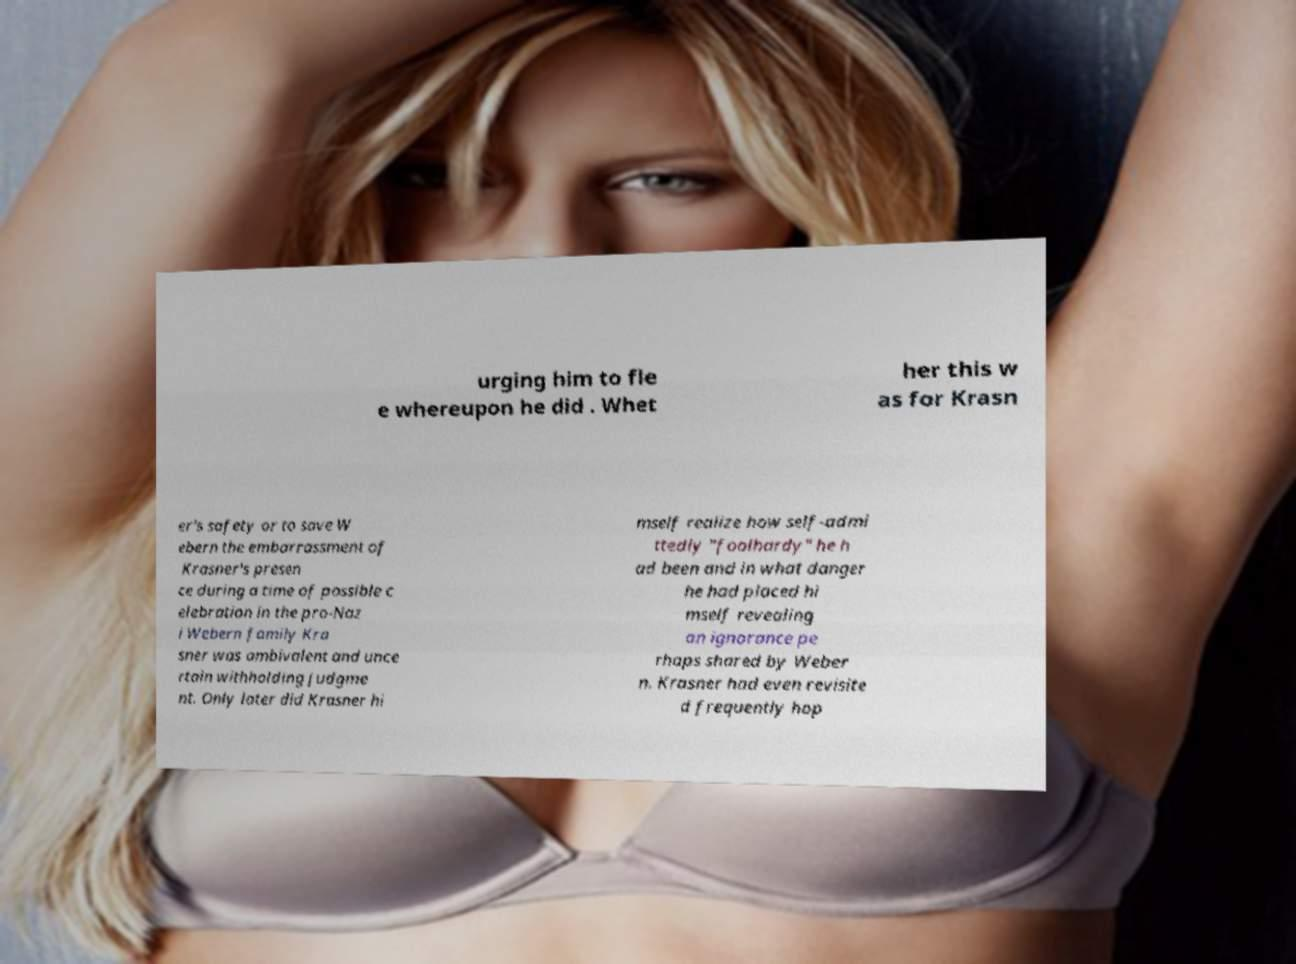I need the written content from this picture converted into text. Can you do that? urging him to fle e whereupon he did . Whet her this w as for Krasn er's safety or to save W ebern the embarrassment of Krasner's presen ce during a time of possible c elebration in the pro-Naz i Webern family Kra sner was ambivalent and unce rtain withholding judgme nt. Only later did Krasner hi mself realize how self-admi ttedly "foolhardy" he h ad been and in what danger he had placed hi mself revealing an ignorance pe rhaps shared by Weber n. Krasner had even revisite d frequently hop 